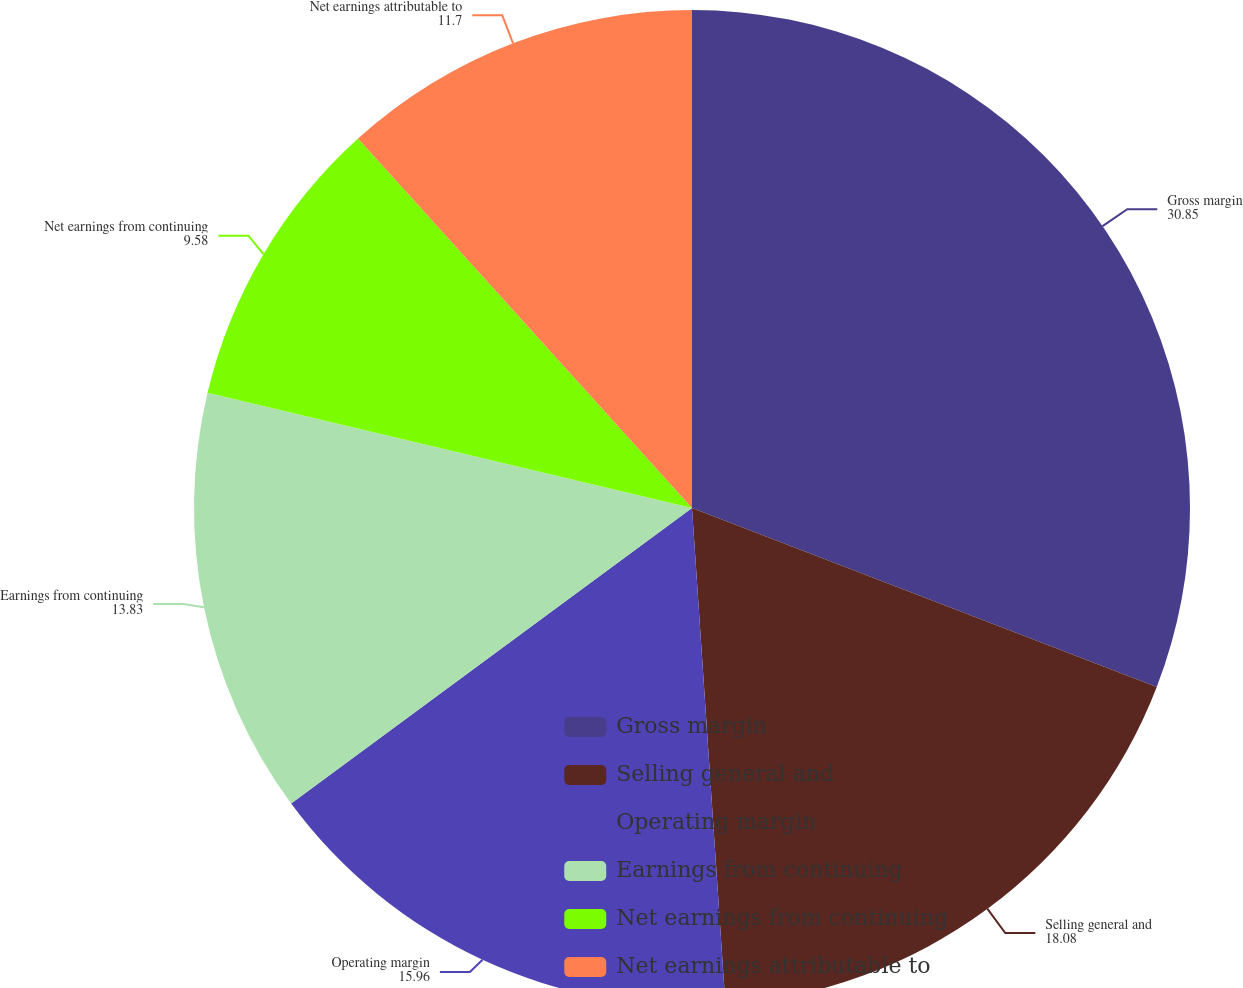Convert chart. <chart><loc_0><loc_0><loc_500><loc_500><pie_chart><fcel>Gross margin<fcel>Selling general and<fcel>Operating margin<fcel>Earnings from continuing<fcel>Net earnings from continuing<fcel>Net earnings attributable to<nl><fcel>30.85%<fcel>18.08%<fcel>15.96%<fcel>13.83%<fcel>9.58%<fcel>11.7%<nl></chart> 